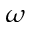Convert formula to latex. <formula><loc_0><loc_0><loc_500><loc_500>\omega</formula> 